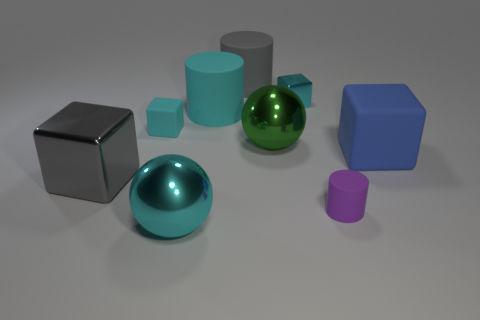Subtract all gray cubes. How many cubes are left? 3 Add 1 big green objects. How many objects exist? 10 Subtract all purple cylinders. How many cylinders are left? 2 Subtract all red spheres. How many cyan cubes are left? 2 Subtract all cylinders. How many objects are left? 6 Subtract 1 cubes. How many cubes are left? 3 Subtract all big cyan cubes. Subtract all cyan metal cubes. How many objects are left? 8 Add 8 big rubber cylinders. How many big rubber cylinders are left? 10 Add 4 tiny blue matte cylinders. How many tiny blue matte cylinders exist? 4 Subtract 0 yellow cubes. How many objects are left? 9 